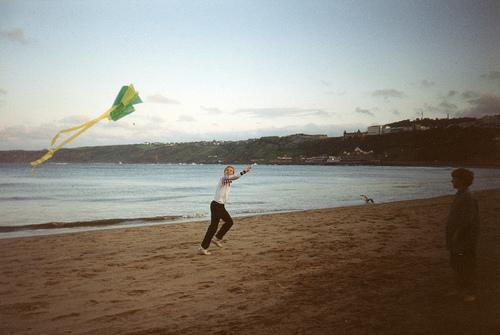How many kites are there?
Give a very brief answer. 1. 